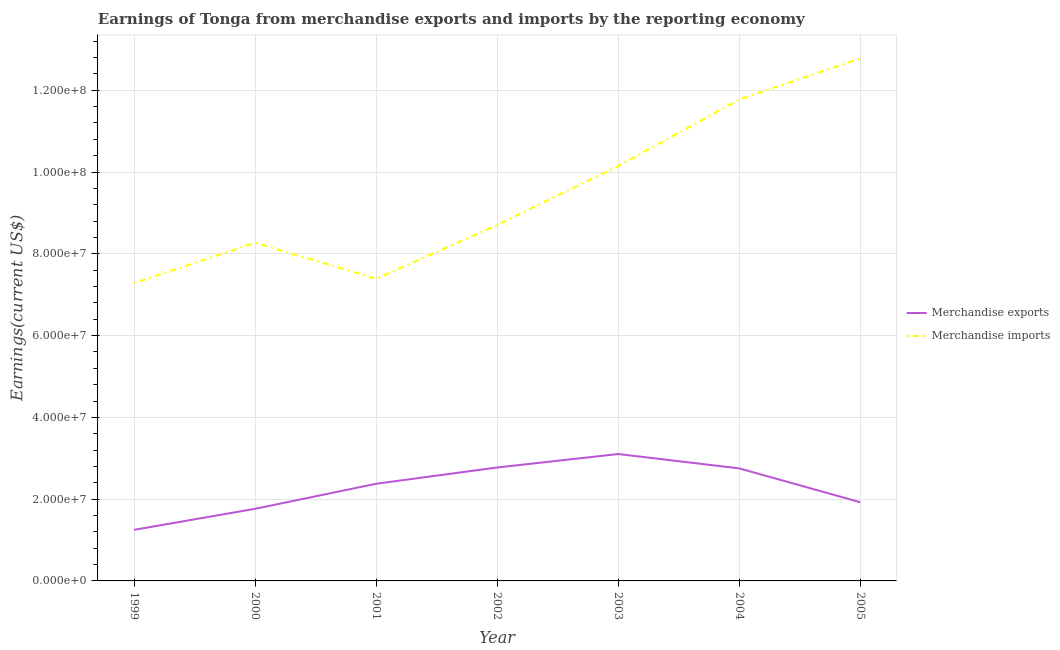Does the line corresponding to earnings from merchandise imports intersect with the line corresponding to earnings from merchandise exports?
Give a very brief answer. No. What is the earnings from merchandise exports in 2001?
Provide a succinct answer. 2.38e+07. Across all years, what is the maximum earnings from merchandise imports?
Make the answer very short. 1.28e+08. Across all years, what is the minimum earnings from merchandise imports?
Offer a very short reply. 7.28e+07. In which year was the earnings from merchandise exports maximum?
Ensure brevity in your answer.  2003. What is the total earnings from merchandise imports in the graph?
Offer a very short reply. 6.63e+08. What is the difference between the earnings from merchandise imports in 2001 and that in 2004?
Give a very brief answer. -4.39e+07. What is the difference between the earnings from merchandise imports in 2002 and the earnings from merchandise exports in 2001?
Keep it short and to the point. 6.33e+07. What is the average earnings from merchandise exports per year?
Offer a terse response. 2.28e+07. In the year 2001, what is the difference between the earnings from merchandise exports and earnings from merchandise imports?
Your answer should be compact. -5.01e+07. What is the ratio of the earnings from merchandise exports in 1999 to that in 2002?
Make the answer very short. 0.45. Is the difference between the earnings from merchandise imports in 2000 and 2004 greater than the difference between the earnings from merchandise exports in 2000 and 2004?
Offer a very short reply. No. What is the difference between the highest and the second highest earnings from merchandise imports?
Offer a very short reply. 1.00e+07. What is the difference between the highest and the lowest earnings from merchandise imports?
Offer a very short reply. 5.49e+07. Is the sum of the earnings from merchandise imports in 2001 and 2003 greater than the maximum earnings from merchandise exports across all years?
Your response must be concise. Yes. Does the earnings from merchandise exports monotonically increase over the years?
Make the answer very short. No. How many lines are there?
Offer a very short reply. 2. How many years are there in the graph?
Offer a terse response. 7. Where does the legend appear in the graph?
Offer a terse response. Center right. How many legend labels are there?
Provide a succinct answer. 2. What is the title of the graph?
Give a very brief answer. Earnings of Tonga from merchandise exports and imports by the reporting economy. What is the label or title of the X-axis?
Offer a very short reply. Year. What is the label or title of the Y-axis?
Give a very brief answer. Earnings(current US$). What is the Earnings(current US$) in Merchandise exports in 1999?
Give a very brief answer. 1.25e+07. What is the Earnings(current US$) of Merchandise imports in 1999?
Your answer should be very brief. 7.28e+07. What is the Earnings(current US$) in Merchandise exports in 2000?
Your response must be concise. 1.76e+07. What is the Earnings(current US$) in Merchandise imports in 2000?
Offer a terse response. 8.27e+07. What is the Earnings(current US$) in Merchandise exports in 2001?
Make the answer very short. 2.38e+07. What is the Earnings(current US$) of Merchandise imports in 2001?
Keep it short and to the point. 7.39e+07. What is the Earnings(current US$) of Merchandise exports in 2002?
Keep it short and to the point. 2.77e+07. What is the Earnings(current US$) in Merchandise imports in 2002?
Offer a very short reply. 8.71e+07. What is the Earnings(current US$) of Merchandise exports in 2003?
Ensure brevity in your answer.  3.10e+07. What is the Earnings(current US$) of Merchandise imports in 2003?
Give a very brief answer. 1.01e+08. What is the Earnings(current US$) of Merchandise exports in 2004?
Your response must be concise. 2.75e+07. What is the Earnings(current US$) of Merchandise imports in 2004?
Your response must be concise. 1.18e+08. What is the Earnings(current US$) of Merchandise exports in 2005?
Keep it short and to the point. 1.92e+07. What is the Earnings(current US$) of Merchandise imports in 2005?
Give a very brief answer. 1.28e+08. Across all years, what is the maximum Earnings(current US$) in Merchandise exports?
Make the answer very short. 3.10e+07. Across all years, what is the maximum Earnings(current US$) of Merchandise imports?
Offer a terse response. 1.28e+08. Across all years, what is the minimum Earnings(current US$) of Merchandise exports?
Provide a succinct answer. 1.25e+07. Across all years, what is the minimum Earnings(current US$) in Merchandise imports?
Offer a very short reply. 7.28e+07. What is the total Earnings(current US$) in Merchandise exports in the graph?
Provide a succinct answer. 1.59e+08. What is the total Earnings(current US$) of Merchandise imports in the graph?
Your response must be concise. 6.63e+08. What is the difference between the Earnings(current US$) of Merchandise exports in 1999 and that in 2000?
Make the answer very short. -5.14e+06. What is the difference between the Earnings(current US$) in Merchandise imports in 1999 and that in 2000?
Keep it short and to the point. -9.87e+06. What is the difference between the Earnings(current US$) in Merchandise exports in 1999 and that in 2001?
Provide a succinct answer. -1.13e+07. What is the difference between the Earnings(current US$) of Merchandise imports in 1999 and that in 2001?
Your answer should be compact. -1.05e+06. What is the difference between the Earnings(current US$) in Merchandise exports in 1999 and that in 2002?
Provide a succinct answer. -1.52e+07. What is the difference between the Earnings(current US$) of Merchandise imports in 1999 and that in 2002?
Provide a succinct answer. -1.42e+07. What is the difference between the Earnings(current US$) of Merchandise exports in 1999 and that in 2003?
Make the answer very short. -1.85e+07. What is the difference between the Earnings(current US$) in Merchandise imports in 1999 and that in 2003?
Offer a terse response. -2.86e+07. What is the difference between the Earnings(current US$) of Merchandise exports in 1999 and that in 2004?
Offer a very short reply. -1.50e+07. What is the difference between the Earnings(current US$) of Merchandise imports in 1999 and that in 2004?
Provide a short and direct response. -4.49e+07. What is the difference between the Earnings(current US$) in Merchandise exports in 1999 and that in 2005?
Provide a succinct answer. -6.75e+06. What is the difference between the Earnings(current US$) in Merchandise imports in 1999 and that in 2005?
Keep it short and to the point. -5.49e+07. What is the difference between the Earnings(current US$) in Merchandise exports in 2000 and that in 2001?
Keep it short and to the point. -6.13e+06. What is the difference between the Earnings(current US$) of Merchandise imports in 2000 and that in 2001?
Your answer should be very brief. 8.82e+06. What is the difference between the Earnings(current US$) of Merchandise exports in 2000 and that in 2002?
Your answer should be very brief. -1.01e+07. What is the difference between the Earnings(current US$) in Merchandise imports in 2000 and that in 2002?
Provide a succinct answer. -4.36e+06. What is the difference between the Earnings(current US$) in Merchandise exports in 2000 and that in 2003?
Offer a very short reply. -1.34e+07. What is the difference between the Earnings(current US$) in Merchandise imports in 2000 and that in 2003?
Your answer should be compact. -1.88e+07. What is the difference between the Earnings(current US$) in Merchandise exports in 2000 and that in 2004?
Offer a terse response. -9.88e+06. What is the difference between the Earnings(current US$) of Merchandise imports in 2000 and that in 2004?
Provide a succinct answer. -3.50e+07. What is the difference between the Earnings(current US$) in Merchandise exports in 2000 and that in 2005?
Your response must be concise. -1.60e+06. What is the difference between the Earnings(current US$) in Merchandise imports in 2000 and that in 2005?
Make the answer very short. -4.51e+07. What is the difference between the Earnings(current US$) in Merchandise exports in 2001 and that in 2002?
Ensure brevity in your answer.  -3.98e+06. What is the difference between the Earnings(current US$) in Merchandise imports in 2001 and that in 2002?
Your answer should be very brief. -1.32e+07. What is the difference between the Earnings(current US$) of Merchandise exports in 2001 and that in 2003?
Give a very brief answer. -7.27e+06. What is the difference between the Earnings(current US$) in Merchandise imports in 2001 and that in 2003?
Ensure brevity in your answer.  -2.76e+07. What is the difference between the Earnings(current US$) in Merchandise exports in 2001 and that in 2004?
Give a very brief answer. -3.75e+06. What is the difference between the Earnings(current US$) in Merchandise imports in 2001 and that in 2004?
Offer a very short reply. -4.39e+07. What is the difference between the Earnings(current US$) in Merchandise exports in 2001 and that in 2005?
Make the answer very short. 4.52e+06. What is the difference between the Earnings(current US$) of Merchandise imports in 2001 and that in 2005?
Offer a terse response. -5.39e+07. What is the difference between the Earnings(current US$) of Merchandise exports in 2002 and that in 2003?
Give a very brief answer. -3.29e+06. What is the difference between the Earnings(current US$) of Merchandise imports in 2002 and that in 2003?
Keep it short and to the point. -1.44e+07. What is the difference between the Earnings(current US$) of Merchandise exports in 2002 and that in 2004?
Your response must be concise. 2.23e+05. What is the difference between the Earnings(current US$) of Merchandise imports in 2002 and that in 2004?
Ensure brevity in your answer.  -3.07e+07. What is the difference between the Earnings(current US$) of Merchandise exports in 2002 and that in 2005?
Your answer should be very brief. 8.50e+06. What is the difference between the Earnings(current US$) of Merchandise imports in 2002 and that in 2005?
Offer a very short reply. -4.07e+07. What is the difference between the Earnings(current US$) in Merchandise exports in 2003 and that in 2004?
Provide a succinct answer. 3.51e+06. What is the difference between the Earnings(current US$) in Merchandise imports in 2003 and that in 2004?
Keep it short and to the point. -1.63e+07. What is the difference between the Earnings(current US$) of Merchandise exports in 2003 and that in 2005?
Keep it short and to the point. 1.18e+07. What is the difference between the Earnings(current US$) in Merchandise imports in 2003 and that in 2005?
Provide a short and direct response. -2.63e+07. What is the difference between the Earnings(current US$) of Merchandise exports in 2004 and that in 2005?
Provide a short and direct response. 8.28e+06. What is the difference between the Earnings(current US$) of Merchandise imports in 2004 and that in 2005?
Ensure brevity in your answer.  -1.00e+07. What is the difference between the Earnings(current US$) in Merchandise exports in 1999 and the Earnings(current US$) in Merchandise imports in 2000?
Provide a short and direct response. -7.02e+07. What is the difference between the Earnings(current US$) of Merchandise exports in 1999 and the Earnings(current US$) of Merchandise imports in 2001?
Your answer should be very brief. -6.14e+07. What is the difference between the Earnings(current US$) of Merchandise exports in 1999 and the Earnings(current US$) of Merchandise imports in 2002?
Your answer should be very brief. -7.46e+07. What is the difference between the Earnings(current US$) in Merchandise exports in 1999 and the Earnings(current US$) in Merchandise imports in 2003?
Ensure brevity in your answer.  -8.90e+07. What is the difference between the Earnings(current US$) in Merchandise exports in 1999 and the Earnings(current US$) in Merchandise imports in 2004?
Offer a very short reply. -1.05e+08. What is the difference between the Earnings(current US$) of Merchandise exports in 1999 and the Earnings(current US$) of Merchandise imports in 2005?
Your response must be concise. -1.15e+08. What is the difference between the Earnings(current US$) of Merchandise exports in 2000 and the Earnings(current US$) of Merchandise imports in 2001?
Offer a terse response. -5.62e+07. What is the difference between the Earnings(current US$) of Merchandise exports in 2000 and the Earnings(current US$) of Merchandise imports in 2002?
Offer a very short reply. -6.94e+07. What is the difference between the Earnings(current US$) of Merchandise exports in 2000 and the Earnings(current US$) of Merchandise imports in 2003?
Provide a succinct answer. -8.38e+07. What is the difference between the Earnings(current US$) of Merchandise exports in 2000 and the Earnings(current US$) of Merchandise imports in 2004?
Ensure brevity in your answer.  -1.00e+08. What is the difference between the Earnings(current US$) in Merchandise exports in 2000 and the Earnings(current US$) in Merchandise imports in 2005?
Offer a very short reply. -1.10e+08. What is the difference between the Earnings(current US$) in Merchandise exports in 2001 and the Earnings(current US$) in Merchandise imports in 2002?
Your answer should be very brief. -6.33e+07. What is the difference between the Earnings(current US$) of Merchandise exports in 2001 and the Earnings(current US$) of Merchandise imports in 2003?
Provide a succinct answer. -7.77e+07. What is the difference between the Earnings(current US$) in Merchandise exports in 2001 and the Earnings(current US$) in Merchandise imports in 2004?
Make the answer very short. -9.40e+07. What is the difference between the Earnings(current US$) of Merchandise exports in 2001 and the Earnings(current US$) of Merchandise imports in 2005?
Offer a terse response. -1.04e+08. What is the difference between the Earnings(current US$) in Merchandise exports in 2002 and the Earnings(current US$) in Merchandise imports in 2003?
Your answer should be very brief. -7.37e+07. What is the difference between the Earnings(current US$) of Merchandise exports in 2002 and the Earnings(current US$) of Merchandise imports in 2004?
Give a very brief answer. -9.00e+07. What is the difference between the Earnings(current US$) in Merchandise exports in 2002 and the Earnings(current US$) in Merchandise imports in 2005?
Your answer should be very brief. -1.00e+08. What is the difference between the Earnings(current US$) of Merchandise exports in 2003 and the Earnings(current US$) of Merchandise imports in 2004?
Your answer should be compact. -8.67e+07. What is the difference between the Earnings(current US$) of Merchandise exports in 2003 and the Earnings(current US$) of Merchandise imports in 2005?
Provide a succinct answer. -9.67e+07. What is the difference between the Earnings(current US$) of Merchandise exports in 2004 and the Earnings(current US$) of Merchandise imports in 2005?
Provide a short and direct response. -1.00e+08. What is the average Earnings(current US$) in Merchandise exports per year?
Your answer should be compact. 2.28e+07. What is the average Earnings(current US$) in Merchandise imports per year?
Make the answer very short. 9.48e+07. In the year 1999, what is the difference between the Earnings(current US$) of Merchandise exports and Earnings(current US$) of Merchandise imports?
Your answer should be compact. -6.03e+07. In the year 2000, what is the difference between the Earnings(current US$) in Merchandise exports and Earnings(current US$) in Merchandise imports?
Your answer should be very brief. -6.51e+07. In the year 2001, what is the difference between the Earnings(current US$) of Merchandise exports and Earnings(current US$) of Merchandise imports?
Offer a terse response. -5.01e+07. In the year 2002, what is the difference between the Earnings(current US$) in Merchandise exports and Earnings(current US$) in Merchandise imports?
Offer a very short reply. -5.93e+07. In the year 2003, what is the difference between the Earnings(current US$) of Merchandise exports and Earnings(current US$) of Merchandise imports?
Keep it short and to the point. -7.04e+07. In the year 2004, what is the difference between the Earnings(current US$) of Merchandise exports and Earnings(current US$) of Merchandise imports?
Your response must be concise. -9.02e+07. In the year 2005, what is the difference between the Earnings(current US$) of Merchandise exports and Earnings(current US$) of Merchandise imports?
Give a very brief answer. -1.09e+08. What is the ratio of the Earnings(current US$) of Merchandise exports in 1999 to that in 2000?
Ensure brevity in your answer.  0.71. What is the ratio of the Earnings(current US$) in Merchandise imports in 1999 to that in 2000?
Offer a terse response. 0.88. What is the ratio of the Earnings(current US$) of Merchandise exports in 1999 to that in 2001?
Ensure brevity in your answer.  0.53. What is the ratio of the Earnings(current US$) in Merchandise imports in 1999 to that in 2001?
Your answer should be very brief. 0.99. What is the ratio of the Earnings(current US$) of Merchandise exports in 1999 to that in 2002?
Provide a short and direct response. 0.45. What is the ratio of the Earnings(current US$) of Merchandise imports in 1999 to that in 2002?
Ensure brevity in your answer.  0.84. What is the ratio of the Earnings(current US$) of Merchandise exports in 1999 to that in 2003?
Provide a short and direct response. 0.4. What is the ratio of the Earnings(current US$) in Merchandise imports in 1999 to that in 2003?
Provide a succinct answer. 0.72. What is the ratio of the Earnings(current US$) in Merchandise exports in 1999 to that in 2004?
Make the answer very short. 0.45. What is the ratio of the Earnings(current US$) in Merchandise imports in 1999 to that in 2004?
Ensure brevity in your answer.  0.62. What is the ratio of the Earnings(current US$) in Merchandise exports in 1999 to that in 2005?
Give a very brief answer. 0.65. What is the ratio of the Earnings(current US$) in Merchandise imports in 1999 to that in 2005?
Ensure brevity in your answer.  0.57. What is the ratio of the Earnings(current US$) in Merchandise exports in 2000 to that in 2001?
Provide a short and direct response. 0.74. What is the ratio of the Earnings(current US$) in Merchandise imports in 2000 to that in 2001?
Offer a very short reply. 1.12. What is the ratio of the Earnings(current US$) of Merchandise exports in 2000 to that in 2002?
Provide a succinct answer. 0.64. What is the ratio of the Earnings(current US$) in Merchandise exports in 2000 to that in 2003?
Give a very brief answer. 0.57. What is the ratio of the Earnings(current US$) in Merchandise imports in 2000 to that in 2003?
Give a very brief answer. 0.82. What is the ratio of the Earnings(current US$) in Merchandise exports in 2000 to that in 2004?
Your answer should be very brief. 0.64. What is the ratio of the Earnings(current US$) in Merchandise imports in 2000 to that in 2004?
Provide a succinct answer. 0.7. What is the ratio of the Earnings(current US$) of Merchandise imports in 2000 to that in 2005?
Ensure brevity in your answer.  0.65. What is the ratio of the Earnings(current US$) of Merchandise exports in 2001 to that in 2002?
Your answer should be compact. 0.86. What is the ratio of the Earnings(current US$) in Merchandise imports in 2001 to that in 2002?
Provide a short and direct response. 0.85. What is the ratio of the Earnings(current US$) of Merchandise exports in 2001 to that in 2003?
Provide a short and direct response. 0.77. What is the ratio of the Earnings(current US$) of Merchandise imports in 2001 to that in 2003?
Your response must be concise. 0.73. What is the ratio of the Earnings(current US$) in Merchandise exports in 2001 to that in 2004?
Ensure brevity in your answer.  0.86. What is the ratio of the Earnings(current US$) in Merchandise imports in 2001 to that in 2004?
Provide a succinct answer. 0.63. What is the ratio of the Earnings(current US$) of Merchandise exports in 2001 to that in 2005?
Your answer should be very brief. 1.24. What is the ratio of the Earnings(current US$) of Merchandise imports in 2001 to that in 2005?
Make the answer very short. 0.58. What is the ratio of the Earnings(current US$) in Merchandise exports in 2002 to that in 2003?
Make the answer very short. 0.89. What is the ratio of the Earnings(current US$) of Merchandise imports in 2002 to that in 2003?
Provide a succinct answer. 0.86. What is the ratio of the Earnings(current US$) of Merchandise exports in 2002 to that in 2004?
Make the answer very short. 1.01. What is the ratio of the Earnings(current US$) of Merchandise imports in 2002 to that in 2004?
Keep it short and to the point. 0.74. What is the ratio of the Earnings(current US$) in Merchandise exports in 2002 to that in 2005?
Ensure brevity in your answer.  1.44. What is the ratio of the Earnings(current US$) in Merchandise imports in 2002 to that in 2005?
Give a very brief answer. 0.68. What is the ratio of the Earnings(current US$) of Merchandise exports in 2003 to that in 2004?
Ensure brevity in your answer.  1.13. What is the ratio of the Earnings(current US$) in Merchandise imports in 2003 to that in 2004?
Make the answer very short. 0.86. What is the ratio of the Earnings(current US$) of Merchandise exports in 2003 to that in 2005?
Provide a short and direct response. 1.61. What is the ratio of the Earnings(current US$) in Merchandise imports in 2003 to that in 2005?
Offer a terse response. 0.79. What is the ratio of the Earnings(current US$) in Merchandise exports in 2004 to that in 2005?
Ensure brevity in your answer.  1.43. What is the ratio of the Earnings(current US$) in Merchandise imports in 2004 to that in 2005?
Provide a succinct answer. 0.92. What is the difference between the highest and the second highest Earnings(current US$) of Merchandise exports?
Your answer should be compact. 3.29e+06. What is the difference between the highest and the second highest Earnings(current US$) of Merchandise imports?
Your answer should be compact. 1.00e+07. What is the difference between the highest and the lowest Earnings(current US$) of Merchandise exports?
Your answer should be very brief. 1.85e+07. What is the difference between the highest and the lowest Earnings(current US$) in Merchandise imports?
Provide a short and direct response. 5.49e+07. 